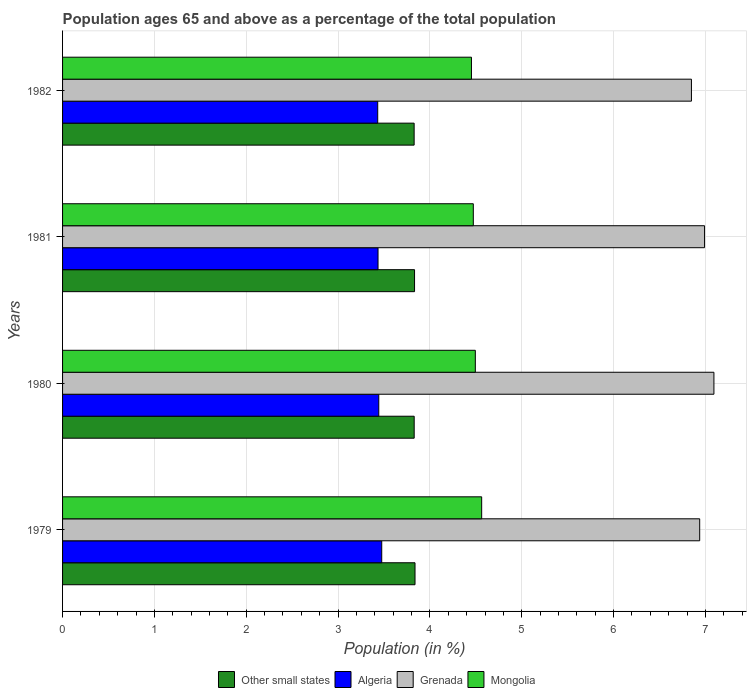How many different coloured bars are there?
Offer a terse response. 4. Are the number of bars per tick equal to the number of legend labels?
Ensure brevity in your answer.  Yes. How many bars are there on the 2nd tick from the top?
Make the answer very short. 4. What is the label of the 4th group of bars from the top?
Offer a terse response. 1979. What is the percentage of the population ages 65 and above in Other small states in 1979?
Make the answer very short. 3.84. Across all years, what is the maximum percentage of the population ages 65 and above in Other small states?
Your answer should be very brief. 3.84. Across all years, what is the minimum percentage of the population ages 65 and above in Mongolia?
Ensure brevity in your answer.  4.45. In which year was the percentage of the population ages 65 and above in Other small states maximum?
Provide a short and direct response. 1979. What is the total percentage of the population ages 65 and above in Grenada in the graph?
Ensure brevity in your answer.  27.87. What is the difference between the percentage of the population ages 65 and above in Other small states in 1979 and that in 1980?
Provide a short and direct response. 0.01. What is the difference between the percentage of the population ages 65 and above in Algeria in 1979 and the percentage of the population ages 65 and above in Other small states in 1980?
Keep it short and to the point. -0.35. What is the average percentage of the population ages 65 and above in Grenada per year?
Provide a short and direct response. 6.97. In the year 1980, what is the difference between the percentage of the population ages 65 and above in Other small states and percentage of the population ages 65 and above in Algeria?
Your response must be concise. 0.39. In how many years, is the percentage of the population ages 65 and above in Grenada greater than 1.4 ?
Your answer should be very brief. 4. What is the ratio of the percentage of the population ages 65 and above in Algeria in 1981 to that in 1982?
Offer a terse response. 1. Is the percentage of the population ages 65 and above in Algeria in 1979 less than that in 1981?
Provide a succinct answer. No. Is the difference between the percentage of the population ages 65 and above in Other small states in 1979 and 1980 greater than the difference between the percentage of the population ages 65 and above in Algeria in 1979 and 1980?
Make the answer very short. No. What is the difference between the highest and the second highest percentage of the population ages 65 and above in Grenada?
Your answer should be very brief. 0.1. What is the difference between the highest and the lowest percentage of the population ages 65 and above in Other small states?
Offer a terse response. 0.01. In how many years, is the percentage of the population ages 65 and above in Mongolia greater than the average percentage of the population ages 65 and above in Mongolia taken over all years?
Your response must be concise. 1. Is the sum of the percentage of the population ages 65 and above in Mongolia in 1980 and 1981 greater than the maximum percentage of the population ages 65 and above in Algeria across all years?
Ensure brevity in your answer.  Yes. Is it the case that in every year, the sum of the percentage of the population ages 65 and above in Algeria and percentage of the population ages 65 and above in Other small states is greater than the sum of percentage of the population ages 65 and above in Grenada and percentage of the population ages 65 and above in Mongolia?
Offer a terse response. Yes. What does the 4th bar from the top in 1982 represents?
Offer a terse response. Other small states. What does the 2nd bar from the bottom in 1982 represents?
Your response must be concise. Algeria. Does the graph contain any zero values?
Keep it short and to the point. No. Where does the legend appear in the graph?
Offer a terse response. Bottom center. How are the legend labels stacked?
Keep it short and to the point. Horizontal. What is the title of the graph?
Offer a terse response. Population ages 65 and above as a percentage of the total population. What is the label or title of the Y-axis?
Provide a short and direct response. Years. What is the Population (in %) in Other small states in 1979?
Your answer should be very brief. 3.84. What is the Population (in %) in Algeria in 1979?
Provide a succinct answer. 3.48. What is the Population (in %) of Grenada in 1979?
Make the answer very short. 6.94. What is the Population (in %) in Mongolia in 1979?
Keep it short and to the point. 4.56. What is the Population (in %) in Other small states in 1980?
Your answer should be very brief. 3.83. What is the Population (in %) in Algeria in 1980?
Provide a short and direct response. 3.44. What is the Population (in %) in Grenada in 1980?
Your response must be concise. 7.09. What is the Population (in %) in Mongolia in 1980?
Give a very brief answer. 4.49. What is the Population (in %) of Other small states in 1981?
Provide a short and direct response. 3.83. What is the Population (in %) in Algeria in 1981?
Give a very brief answer. 3.44. What is the Population (in %) in Grenada in 1981?
Your response must be concise. 6.99. What is the Population (in %) in Mongolia in 1981?
Your answer should be very brief. 4.47. What is the Population (in %) of Other small states in 1982?
Make the answer very short. 3.83. What is the Population (in %) in Algeria in 1982?
Provide a succinct answer. 3.43. What is the Population (in %) in Grenada in 1982?
Your answer should be compact. 6.85. What is the Population (in %) in Mongolia in 1982?
Your answer should be compact. 4.45. Across all years, what is the maximum Population (in %) of Other small states?
Give a very brief answer. 3.84. Across all years, what is the maximum Population (in %) of Algeria?
Provide a short and direct response. 3.48. Across all years, what is the maximum Population (in %) of Grenada?
Make the answer very short. 7.09. Across all years, what is the maximum Population (in %) of Mongolia?
Keep it short and to the point. 4.56. Across all years, what is the minimum Population (in %) in Other small states?
Provide a succinct answer. 3.83. Across all years, what is the minimum Population (in %) of Algeria?
Offer a terse response. 3.43. Across all years, what is the minimum Population (in %) in Grenada?
Your answer should be very brief. 6.85. Across all years, what is the minimum Population (in %) in Mongolia?
Offer a very short reply. 4.45. What is the total Population (in %) of Other small states in the graph?
Your answer should be very brief. 15.33. What is the total Population (in %) in Algeria in the graph?
Offer a terse response. 13.79. What is the total Population (in %) in Grenada in the graph?
Make the answer very short. 27.87. What is the total Population (in %) in Mongolia in the graph?
Your answer should be compact. 17.98. What is the difference between the Population (in %) of Other small states in 1979 and that in 1980?
Provide a succinct answer. 0.01. What is the difference between the Population (in %) of Algeria in 1979 and that in 1980?
Provide a short and direct response. 0.03. What is the difference between the Population (in %) of Grenada in 1979 and that in 1980?
Your answer should be compact. -0.15. What is the difference between the Population (in %) of Mongolia in 1979 and that in 1980?
Give a very brief answer. 0.07. What is the difference between the Population (in %) in Other small states in 1979 and that in 1981?
Keep it short and to the point. 0.01. What is the difference between the Population (in %) of Algeria in 1979 and that in 1981?
Offer a terse response. 0.04. What is the difference between the Population (in %) of Grenada in 1979 and that in 1981?
Provide a short and direct response. -0.05. What is the difference between the Population (in %) of Mongolia in 1979 and that in 1981?
Offer a very short reply. 0.09. What is the difference between the Population (in %) of Other small states in 1979 and that in 1982?
Make the answer very short. 0.01. What is the difference between the Population (in %) in Algeria in 1979 and that in 1982?
Ensure brevity in your answer.  0.04. What is the difference between the Population (in %) in Grenada in 1979 and that in 1982?
Your answer should be very brief. 0.09. What is the difference between the Population (in %) of Mongolia in 1979 and that in 1982?
Ensure brevity in your answer.  0.11. What is the difference between the Population (in %) in Other small states in 1980 and that in 1981?
Make the answer very short. -0. What is the difference between the Population (in %) in Algeria in 1980 and that in 1981?
Give a very brief answer. 0.01. What is the difference between the Population (in %) of Grenada in 1980 and that in 1981?
Offer a terse response. 0.1. What is the difference between the Population (in %) of Mongolia in 1980 and that in 1981?
Ensure brevity in your answer.  0.02. What is the difference between the Population (in %) in Algeria in 1980 and that in 1982?
Keep it short and to the point. 0.01. What is the difference between the Population (in %) in Grenada in 1980 and that in 1982?
Give a very brief answer. 0.24. What is the difference between the Population (in %) of Mongolia in 1980 and that in 1982?
Ensure brevity in your answer.  0.04. What is the difference between the Population (in %) in Other small states in 1981 and that in 1982?
Ensure brevity in your answer.  0. What is the difference between the Population (in %) in Algeria in 1981 and that in 1982?
Give a very brief answer. 0. What is the difference between the Population (in %) of Grenada in 1981 and that in 1982?
Give a very brief answer. 0.14. What is the difference between the Population (in %) in Mongolia in 1981 and that in 1982?
Your answer should be very brief. 0.02. What is the difference between the Population (in %) of Other small states in 1979 and the Population (in %) of Algeria in 1980?
Provide a short and direct response. 0.39. What is the difference between the Population (in %) of Other small states in 1979 and the Population (in %) of Grenada in 1980?
Your answer should be compact. -3.25. What is the difference between the Population (in %) of Other small states in 1979 and the Population (in %) of Mongolia in 1980?
Offer a terse response. -0.66. What is the difference between the Population (in %) of Algeria in 1979 and the Population (in %) of Grenada in 1980?
Your answer should be very brief. -3.62. What is the difference between the Population (in %) of Algeria in 1979 and the Population (in %) of Mongolia in 1980?
Give a very brief answer. -1.02. What is the difference between the Population (in %) in Grenada in 1979 and the Population (in %) in Mongolia in 1980?
Provide a short and direct response. 2.44. What is the difference between the Population (in %) of Other small states in 1979 and the Population (in %) of Algeria in 1981?
Offer a terse response. 0.4. What is the difference between the Population (in %) in Other small states in 1979 and the Population (in %) in Grenada in 1981?
Ensure brevity in your answer.  -3.15. What is the difference between the Population (in %) of Other small states in 1979 and the Population (in %) of Mongolia in 1981?
Your answer should be compact. -0.63. What is the difference between the Population (in %) of Algeria in 1979 and the Population (in %) of Grenada in 1981?
Provide a succinct answer. -3.52. What is the difference between the Population (in %) in Algeria in 1979 and the Population (in %) in Mongolia in 1981?
Your answer should be very brief. -1. What is the difference between the Population (in %) of Grenada in 1979 and the Population (in %) of Mongolia in 1981?
Keep it short and to the point. 2.47. What is the difference between the Population (in %) in Other small states in 1979 and the Population (in %) in Algeria in 1982?
Your response must be concise. 0.41. What is the difference between the Population (in %) of Other small states in 1979 and the Population (in %) of Grenada in 1982?
Your answer should be very brief. -3.01. What is the difference between the Population (in %) in Other small states in 1979 and the Population (in %) in Mongolia in 1982?
Keep it short and to the point. -0.61. What is the difference between the Population (in %) of Algeria in 1979 and the Population (in %) of Grenada in 1982?
Provide a short and direct response. -3.37. What is the difference between the Population (in %) in Algeria in 1979 and the Population (in %) in Mongolia in 1982?
Give a very brief answer. -0.98. What is the difference between the Population (in %) in Grenada in 1979 and the Population (in %) in Mongolia in 1982?
Your answer should be compact. 2.49. What is the difference between the Population (in %) of Other small states in 1980 and the Population (in %) of Algeria in 1981?
Your answer should be very brief. 0.39. What is the difference between the Population (in %) of Other small states in 1980 and the Population (in %) of Grenada in 1981?
Provide a succinct answer. -3.16. What is the difference between the Population (in %) of Other small states in 1980 and the Population (in %) of Mongolia in 1981?
Your response must be concise. -0.64. What is the difference between the Population (in %) in Algeria in 1980 and the Population (in %) in Grenada in 1981?
Ensure brevity in your answer.  -3.55. What is the difference between the Population (in %) in Algeria in 1980 and the Population (in %) in Mongolia in 1981?
Your answer should be very brief. -1.03. What is the difference between the Population (in %) of Grenada in 1980 and the Population (in %) of Mongolia in 1981?
Provide a short and direct response. 2.62. What is the difference between the Population (in %) of Other small states in 1980 and the Population (in %) of Algeria in 1982?
Offer a very short reply. 0.4. What is the difference between the Population (in %) in Other small states in 1980 and the Population (in %) in Grenada in 1982?
Offer a very short reply. -3.02. What is the difference between the Population (in %) in Other small states in 1980 and the Population (in %) in Mongolia in 1982?
Offer a very short reply. -0.62. What is the difference between the Population (in %) of Algeria in 1980 and the Population (in %) of Grenada in 1982?
Provide a short and direct response. -3.4. What is the difference between the Population (in %) of Algeria in 1980 and the Population (in %) of Mongolia in 1982?
Ensure brevity in your answer.  -1.01. What is the difference between the Population (in %) in Grenada in 1980 and the Population (in %) in Mongolia in 1982?
Provide a succinct answer. 2.64. What is the difference between the Population (in %) of Other small states in 1981 and the Population (in %) of Algeria in 1982?
Offer a very short reply. 0.4. What is the difference between the Population (in %) in Other small states in 1981 and the Population (in %) in Grenada in 1982?
Offer a very short reply. -3.02. What is the difference between the Population (in %) in Other small states in 1981 and the Population (in %) in Mongolia in 1982?
Provide a succinct answer. -0.62. What is the difference between the Population (in %) in Algeria in 1981 and the Population (in %) in Grenada in 1982?
Offer a terse response. -3.41. What is the difference between the Population (in %) of Algeria in 1981 and the Population (in %) of Mongolia in 1982?
Give a very brief answer. -1.02. What is the difference between the Population (in %) in Grenada in 1981 and the Population (in %) in Mongolia in 1982?
Ensure brevity in your answer.  2.54. What is the average Population (in %) in Other small states per year?
Your answer should be compact. 3.83. What is the average Population (in %) in Algeria per year?
Provide a short and direct response. 3.45. What is the average Population (in %) in Grenada per year?
Offer a very short reply. 6.97. What is the average Population (in %) of Mongolia per year?
Make the answer very short. 4.5. In the year 1979, what is the difference between the Population (in %) of Other small states and Population (in %) of Algeria?
Offer a terse response. 0.36. In the year 1979, what is the difference between the Population (in %) in Other small states and Population (in %) in Grenada?
Keep it short and to the point. -3.1. In the year 1979, what is the difference between the Population (in %) in Other small states and Population (in %) in Mongolia?
Make the answer very short. -0.73. In the year 1979, what is the difference between the Population (in %) of Algeria and Population (in %) of Grenada?
Your response must be concise. -3.46. In the year 1979, what is the difference between the Population (in %) in Algeria and Population (in %) in Mongolia?
Your response must be concise. -1.09. In the year 1979, what is the difference between the Population (in %) of Grenada and Population (in %) of Mongolia?
Ensure brevity in your answer.  2.37. In the year 1980, what is the difference between the Population (in %) in Other small states and Population (in %) in Algeria?
Provide a short and direct response. 0.39. In the year 1980, what is the difference between the Population (in %) of Other small states and Population (in %) of Grenada?
Offer a very short reply. -3.26. In the year 1980, what is the difference between the Population (in %) of Other small states and Population (in %) of Mongolia?
Keep it short and to the point. -0.67. In the year 1980, what is the difference between the Population (in %) of Algeria and Population (in %) of Grenada?
Provide a succinct answer. -3.65. In the year 1980, what is the difference between the Population (in %) in Algeria and Population (in %) in Mongolia?
Offer a terse response. -1.05. In the year 1980, what is the difference between the Population (in %) in Grenada and Population (in %) in Mongolia?
Your answer should be very brief. 2.6. In the year 1981, what is the difference between the Population (in %) of Other small states and Population (in %) of Algeria?
Offer a very short reply. 0.4. In the year 1981, what is the difference between the Population (in %) in Other small states and Population (in %) in Grenada?
Make the answer very short. -3.16. In the year 1981, what is the difference between the Population (in %) of Other small states and Population (in %) of Mongolia?
Provide a short and direct response. -0.64. In the year 1981, what is the difference between the Population (in %) of Algeria and Population (in %) of Grenada?
Make the answer very short. -3.56. In the year 1981, what is the difference between the Population (in %) in Algeria and Population (in %) in Mongolia?
Provide a short and direct response. -1.04. In the year 1981, what is the difference between the Population (in %) of Grenada and Population (in %) of Mongolia?
Your answer should be compact. 2.52. In the year 1982, what is the difference between the Population (in %) of Other small states and Population (in %) of Algeria?
Make the answer very short. 0.4. In the year 1982, what is the difference between the Population (in %) of Other small states and Population (in %) of Grenada?
Provide a short and direct response. -3.02. In the year 1982, what is the difference between the Population (in %) of Other small states and Population (in %) of Mongolia?
Make the answer very short. -0.62. In the year 1982, what is the difference between the Population (in %) of Algeria and Population (in %) of Grenada?
Make the answer very short. -3.42. In the year 1982, what is the difference between the Population (in %) in Algeria and Population (in %) in Mongolia?
Provide a short and direct response. -1.02. In the year 1982, what is the difference between the Population (in %) in Grenada and Population (in %) in Mongolia?
Make the answer very short. 2.4. What is the ratio of the Population (in %) of Other small states in 1979 to that in 1980?
Offer a terse response. 1. What is the ratio of the Population (in %) of Algeria in 1979 to that in 1980?
Your response must be concise. 1.01. What is the ratio of the Population (in %) in Grenada in 1979 to that in 1980?
Make the answer very short. 0.98. What is the ratio of the Population (in %) in Mongolia in 1979 to that in 1980?
Your answer should be very brief. 1.02. What is the ratio of the Population (in %) in Algeria in 1979 to that in 1981?
Provide a short and direct response. 1.01. What is the ratio of the Population (in %) in Grenada in 1979 to that in 1981?
Ensure brevity in your answer.  0.99. What is the ratio of the Population (in %) of Mongolia in 1979 to that in 1981?
Ensure brevity in your answer.  1.02. What is the ratio of the Population (in %) of Other small states in 1979 to that in 1982?
Provide a short and direct response. 1. What is the ratio of the Population (in %) of Algeria in 1979 to that in 1982?
Give a very brief answer. 1.01. What is the ratio of the Population (in %) in Grenada in 1979 to that in 1982?
Make the answer very short. 1.01. What is the ratio of the Population (in %) of Mongolia in 1979 to that in 1982?
Give a very brief answer. 1.02. What is the ratio of the Population (in %) of Other small states in 1980 to that in 1981?
Keep it short and to the point. 1. What is the ratio of the Population (in %) of Algeria in 1980 to that in 1981?
Give a very brief answer. 1. What is the ratio of the Population (in %) in Grenada in 1980 to that in 1981?
Your answer should be compact. 1.01. What is the ratio of the Population (in %) in Mongolia in 1980 to that in 1981?
Provide a short and direct response. 1. What is the ratio of the Population (in %) of Grenada in 1980 to that in 1982?
Make the answer very short. 1.04. What is the ratio of the Population (in %) of Mongolia in 1980 to that in 1982?
Give a very brief answer. 1.01. What is the ratio of the Population (in %) in Grenada in 1981 to that in 1982?
Your answer should be compact. 1.02. What is the ratio of the Population (in %) in Mongolia in 1981 to that in 1982?
Make the answer very short. 1. What is the difference between the highest and the second highest Population (in %) of Other small states?
Provide a succinct answer. 0.01. What is the difference between the highest and the second highest Population (in %) of Algeria?
Your answer should be very brief. 0.03. What is the difference between the highest and the second highest Population (in %) in Grenada?
Keep it short and to the point. 0.1. What is the difference between the highest and the second highest Population (in %) in Mongolia?
Keep it short and to the point. 0.07. What is the difference between the highest and the lowest Population (in %) of Other small states?
Offer a very short reply. 0.01. What is the difference between the highest and the lowest Population (in %) of Algeria?
Give a very brief answer. 0.04. What is the difference between the highest and the lowest Population (in %) in Grenada?
Your answer should be compact. 0.24. What is the difference between the highest and the lowest Population (in %) of Mongolia?
Make the answer very short. 0.11. 